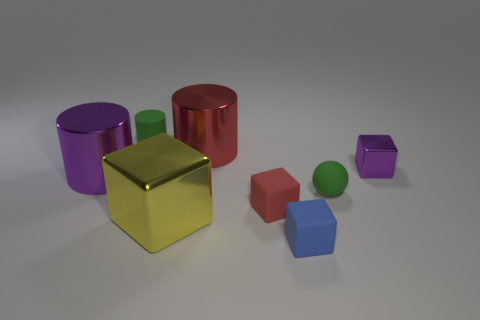There is a ball; does it have the same color as the cube that is on the right side of the blue matte cube? The ball does not have the same color as the cube to the right side of the blue matte cube. The ball is green, while the cube in question appears to be red. 